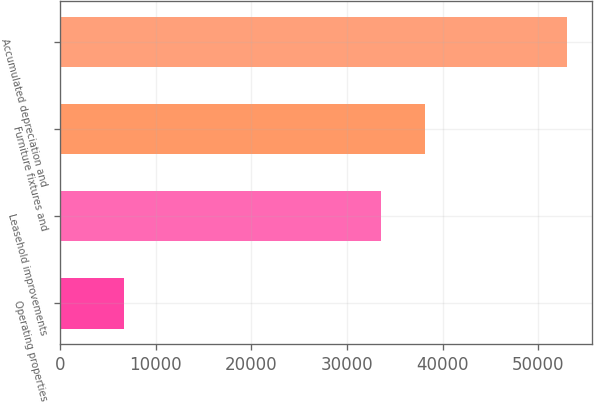<chart> <loc_0><loc_0><loc_500><loc_500><bar_chart><fcel>Operating properties<fcel>Leasehold improvements<fcel>Furniture fixtures and<fcel>Accumulated depreciation and<nl><fcel>6683<fcel>33544<fcel>38174.8<fcel>52991<nl></chart> 